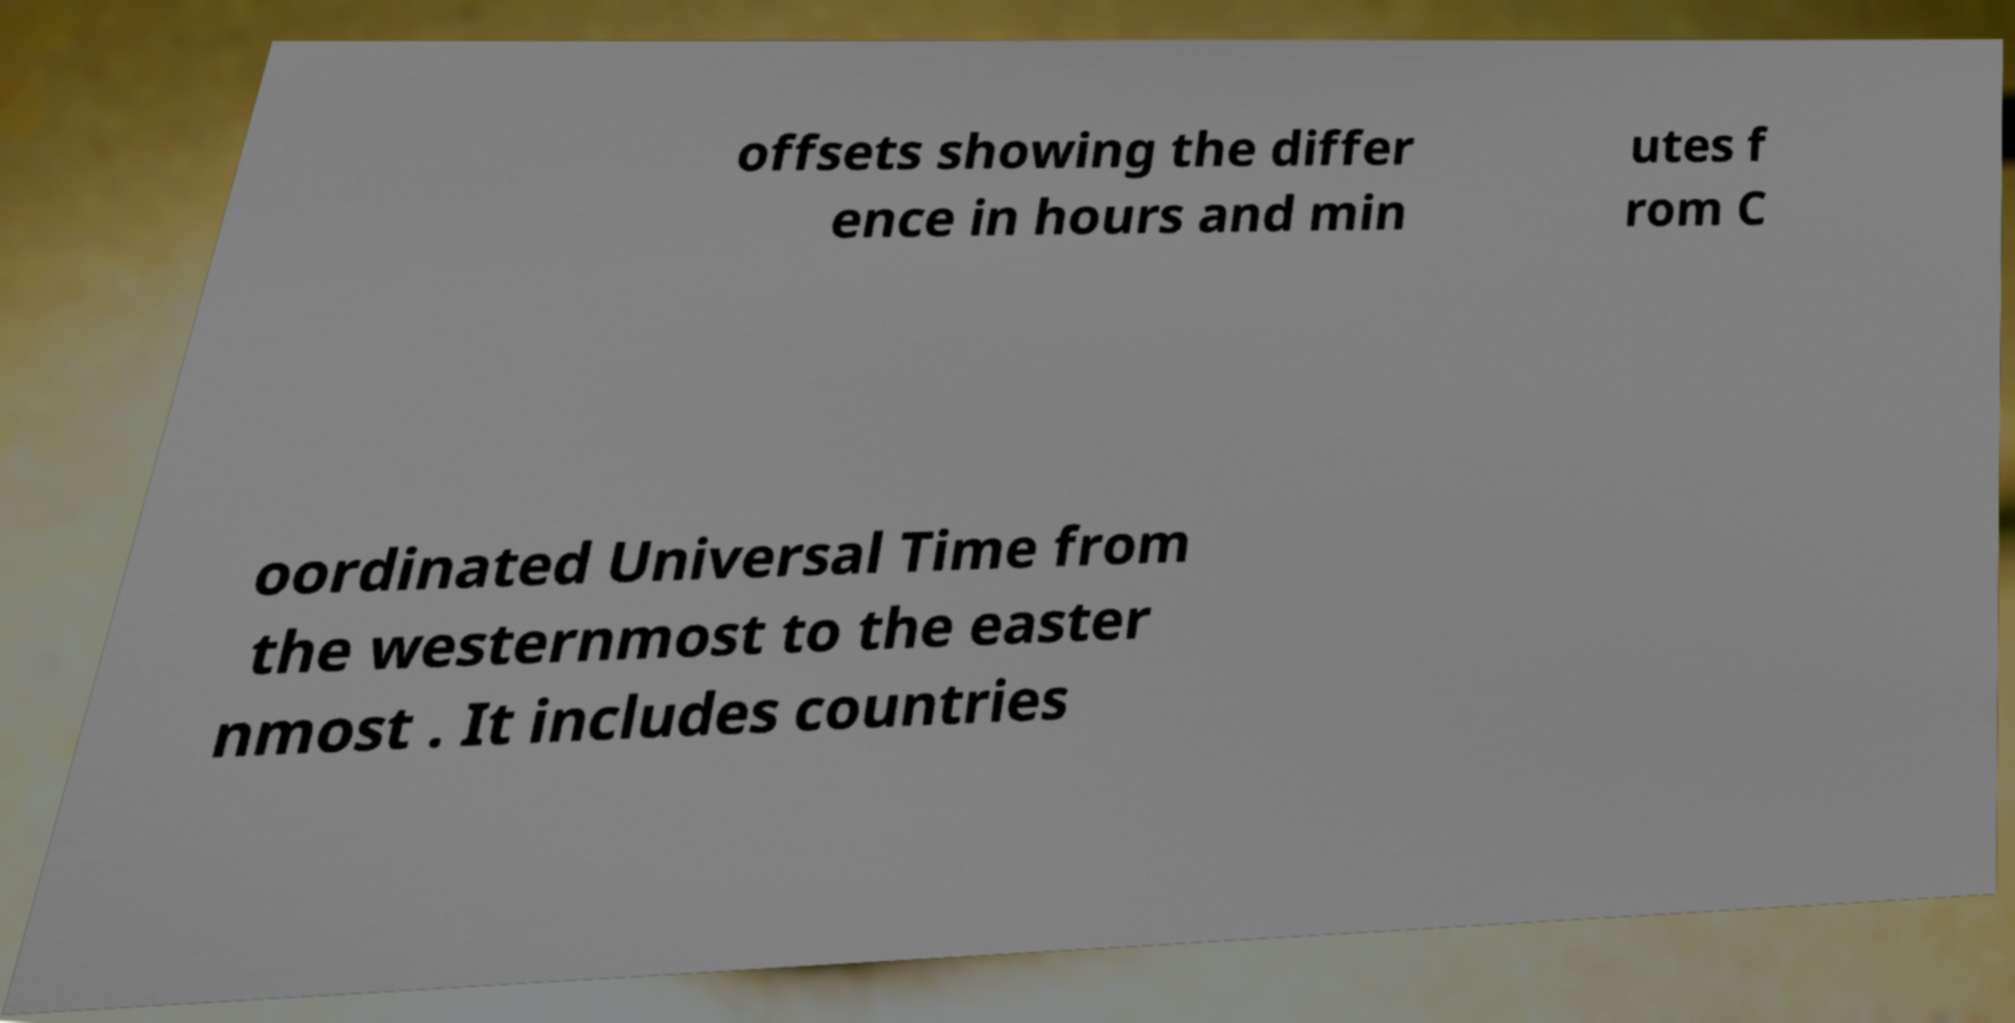Please identify and transcribe the text found in this image. offsets showing the differ ence in hours and min utes f rom C oordinated Universal Time from the westernmost to the easter nmost . It includes countries 